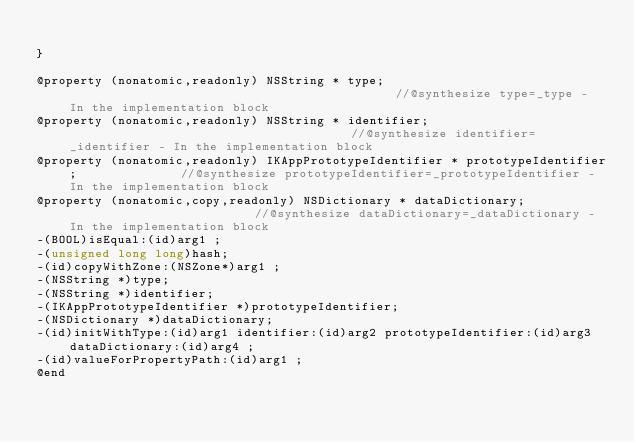<code> <loc_0><loc_0><loc_500><loc_500><_C_>
}

@property (nonatomic,readonly) NSString * type;                                             //@synthesize type=_type - In the implementation block
@property (nonatomic,readonly) NSString * identifier;                                       //@synthesize identifier=_identifier - In the implementation block
@property (nonatomic,readonly) IKAppPrototypeIdentifier * prototypeIdentifier;              //@synthesize prototypeIdentifier=_prototypeIdentifier - In the implementation block
@property (nonatomic,copy,readonly) NSDictionary * dataDictionary;                          //@synthesize dataDictionary=_dataDictionary - In the implementation block
-(BOOL)isEqual:(id)arg1 ;
-(unsigned long long)hash;
-(id)copyWithZone:(NSZone*)arg1 ;
-(NSString *)type;
-(NSString *)identifier;
-(IKAppPrototypeIdentifier *)prototypeIdentifier;
-(NSDictionary *)dataDictionary;
-(id)initWithType:(id)arg1 identifier:(id)arg2 prototypeIdentifier:(id)arg3 dataDictionary:(id)arg4 ;
-(id)valueForPropertyPath:(id)arg1 ;
@end

</code> 